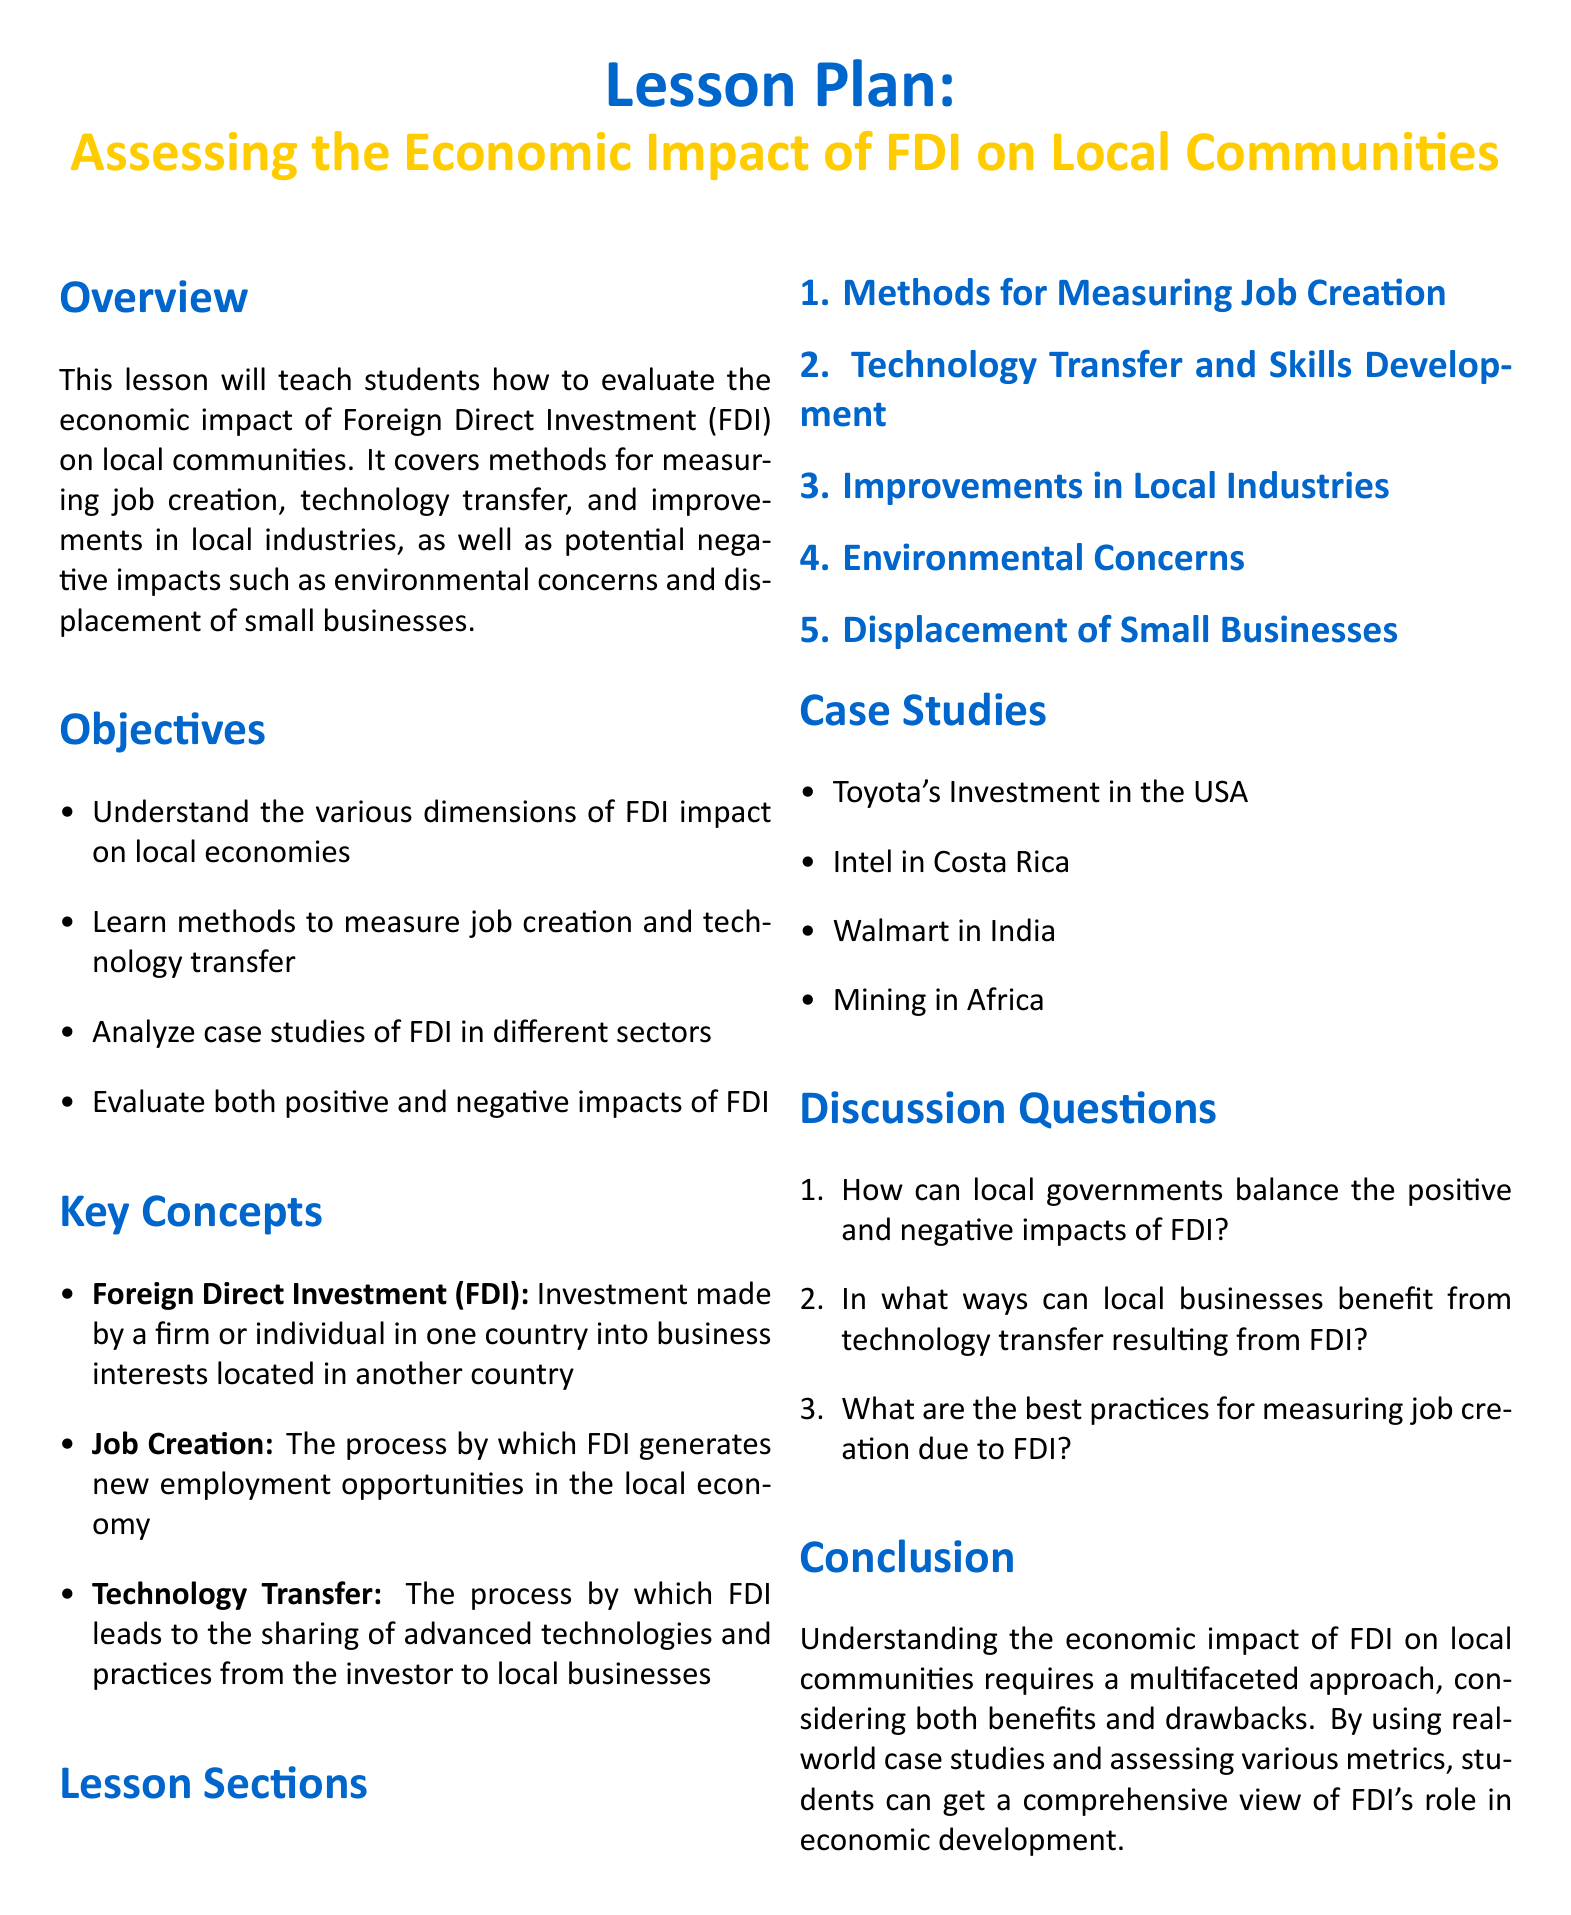What are the key concepts covered in the lesson? The key concepts outline the main topics discussed in the lesson plan, including Foreign Direct Investment, job creation, and technology transfer.
Answer: Foreign Direct Investment, Job Creation, Technology Transfer How many sections are in the lesson? The lesson sections are explicitly listed in the document, and there are five distinct sections.
Answer: 5 What is one of the expected objectives of the lesson? The objectives detail what students will learn from the lesson, including understanding FDI impacts on local economies.
Answer: Understand FDI impact on local economies Name a case study mentioned in the lesson plan. The case studies provided illustrate real-world examples of FDI, including specific companies and regions.
Answer: Toyota's Investment in the USA What is a potential negative impact of FDI discussed? The lesson addresses both positive and negative impacts, including environmental concerns as one of the negatives.
Answer: Environmental concerns What is the purpose of the lesson plan? The overview section specifically articulates the aim of the lesson, which is to teach students how to evaluate FDI's economic impact.
Answer: To evaluate the economic impact of FDI on local communities How can local businesses benefit from technology transfer? This is one of the discussion questions that prompts analysis of advantages for local businesses from FDI.
Answer: Technology transfer What does FDI stand for? The document defines the acronym at the beginning of the lesson plan.
Answer: Foreign Direct Investment 